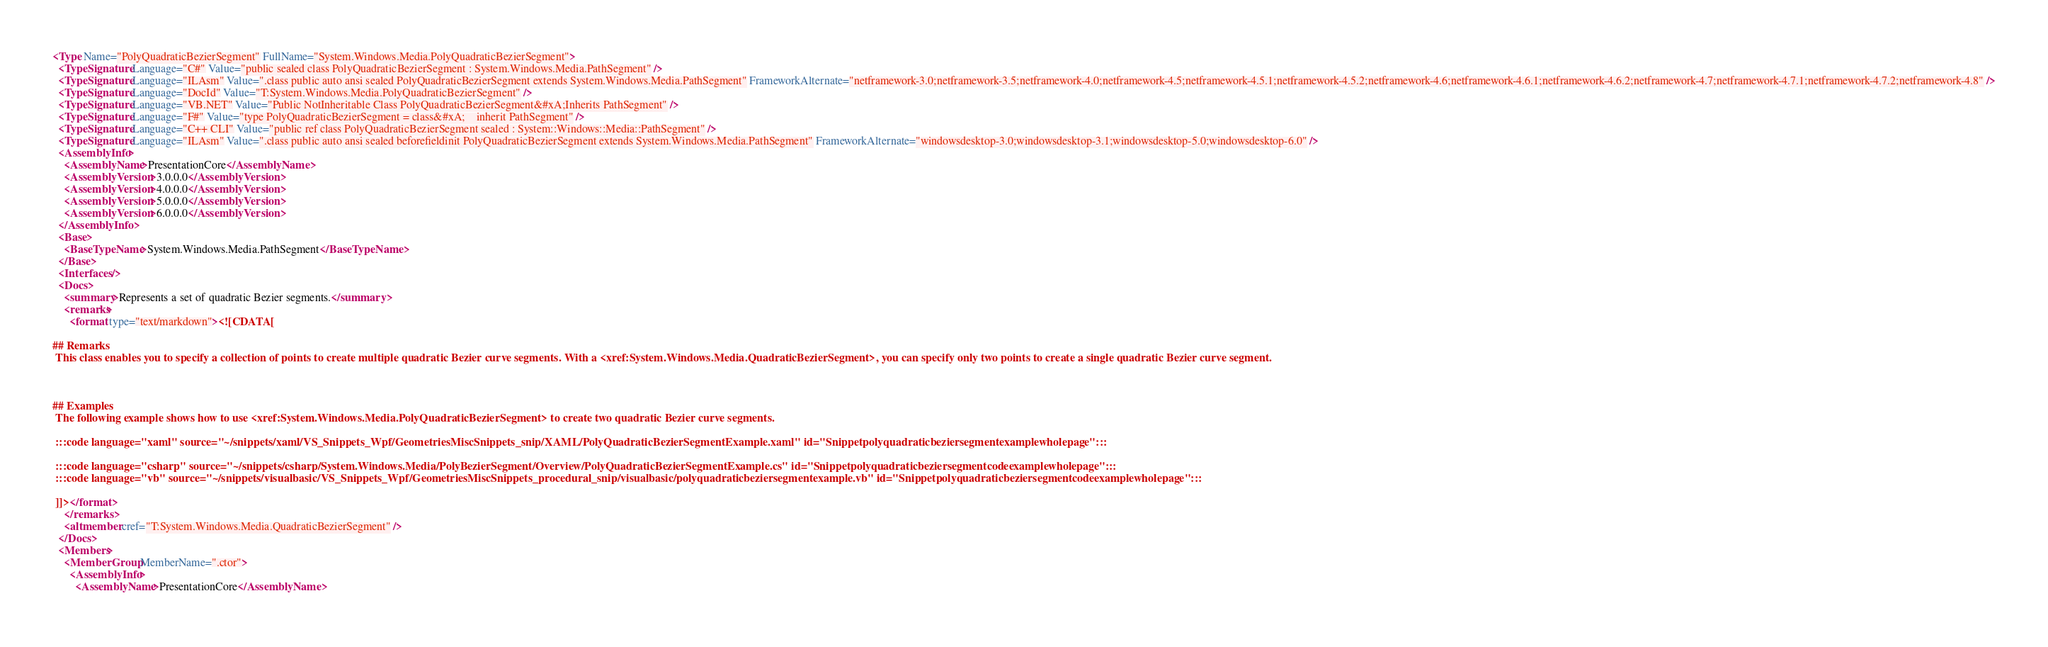<code> <loc_0><loc_0><loc_500><loc_500><_XML_><Type Name="PolyQuadraticBezierSegment" FullName="System.Windows.Media.PolyQuadraticBezierSegment">
  <TypeSignature Language="C#" Value="public sealed class PolyQuadraticBezierSegment : System.Windows.Media.PathSegment" />
  <TypeSignature Language="ILAsm" Value=".class public auto ansi sealed PolyQuadraticBezierSegment extends System.Windows.Media.PathSegment" FrameworkAlternate="netframework-3.0;netframework-3.5;netframework-4.0;netframework-4.5;netframework-4.5.1;netframework-4.5.2;netframework-4.6;netframework-4.6.1;netframework-4.6.2;netframework-4.7;netframework-4.7.1;netframework-4.7.2;netframework-4.8" />
  <TypeSignature Language="DocId" Value="T:System.Windows.Media.PolyQuadraticBezierSegment" />
  <TypeSignature Language="VB.NET" Value="Public NotInheritable Class PolyQuadraticBezierSegment&#xA;Inherits PathSegment" />
  <TypeSignature Language="F#" Value="type PolyQuadraticBezierSegment = class&#xA;    inherit PathSegment" />
  <TypeSignature Language="C++ CLI" Value="public ref class PolyQuadraticBezierSegment sealed : System::Windows::Media::PathSegment" />
  <TypeSignature Language="ILAsm" Value=".class public auto ansi sealed beforefieldinit PolyQuadraticBezierSegment extends System.Windows.Media.PathSegment" FrameworkAlternate="windowsdesktop-3.0;windowsdesktop-3.1;windowsdesktop-5.0;windowsdesktop-6.0" />
  <AssemblyInfo>
    <AssemblyName>PresentationCore</AssemblyName>
    <AssemblyVersion>3.0.0.0</AssemblyVersion>
    <AssemblyVersion>4.0.0.0</AssemblyVersion>
    <AssemblyVersion>5.0.0.0</AssemblyVersion>
    <AssemblyVersion>6.0.0.0</AssemblyVersion>
  </AssemblyInfo>
  <Base>
    <BaseTypeName>System.Windows.Media.PathSegment</BaseTypeName>
  </Base>
  <Interfaces />
  <Docs>
    <summary>Represents a set of quadratic Bezier segments.</summary>
    <remarks>
      <format type="text/markdown"><![CDATA[  
  
## Remarks  
 This class enables you to specify a collection of points to create multiple quadratic Bezier curve segments. With a <xref:System.Windows.Media.QuadraticBezierSegment>, you can specify only two points to create a single quadratic Bezier curve segment.  
  
   
  
## Examples  
 The following example shows how to use <xref:System.Windows.Media.PolyQuadraticBezierSegment> to create two quadratic Bezier curve segments.  
  
 :::code language="xaml" source="~/snippets/xaml/VS_Snippets_Wpf/GeometriesMiscSnippets_snip/XAML/PolyQuadraticBezierSegmentExample.xaml" id="Snippetpolyquadraticbeziersegmentexamplewholepage":::  
  
 :::code language="csharp" source="~/snippets/csharp/System.Windows.Media/PolyBezierSegment/Overview/PolyQuadraticBezierSegmentExample.cs" id="Snippetpolyquadraticbeziersegmentcodeexamplewholepage":::
 :::code language="vb" source="~/snippets/visualbasic/VS_Snippets_Wpf/GeometriesMiscSnippets_procedural_snip/visualbasic/polyquadraticbeziersegmentexample.vb" id="Snippetpolyquadraticbeziersegmentcodeexamplewholepage":::  
  
 ]]></format>
    </remarks>
    <altmember cref="T:System.Windows.Media.QuadraticBezierSegment" />
  </Docs>
  <Members>
    <MemberGroup MemberName=".ctor">
      <AssemblyInfo>
        <AssemblyName>PresentationCore</AssemblyName></code> 